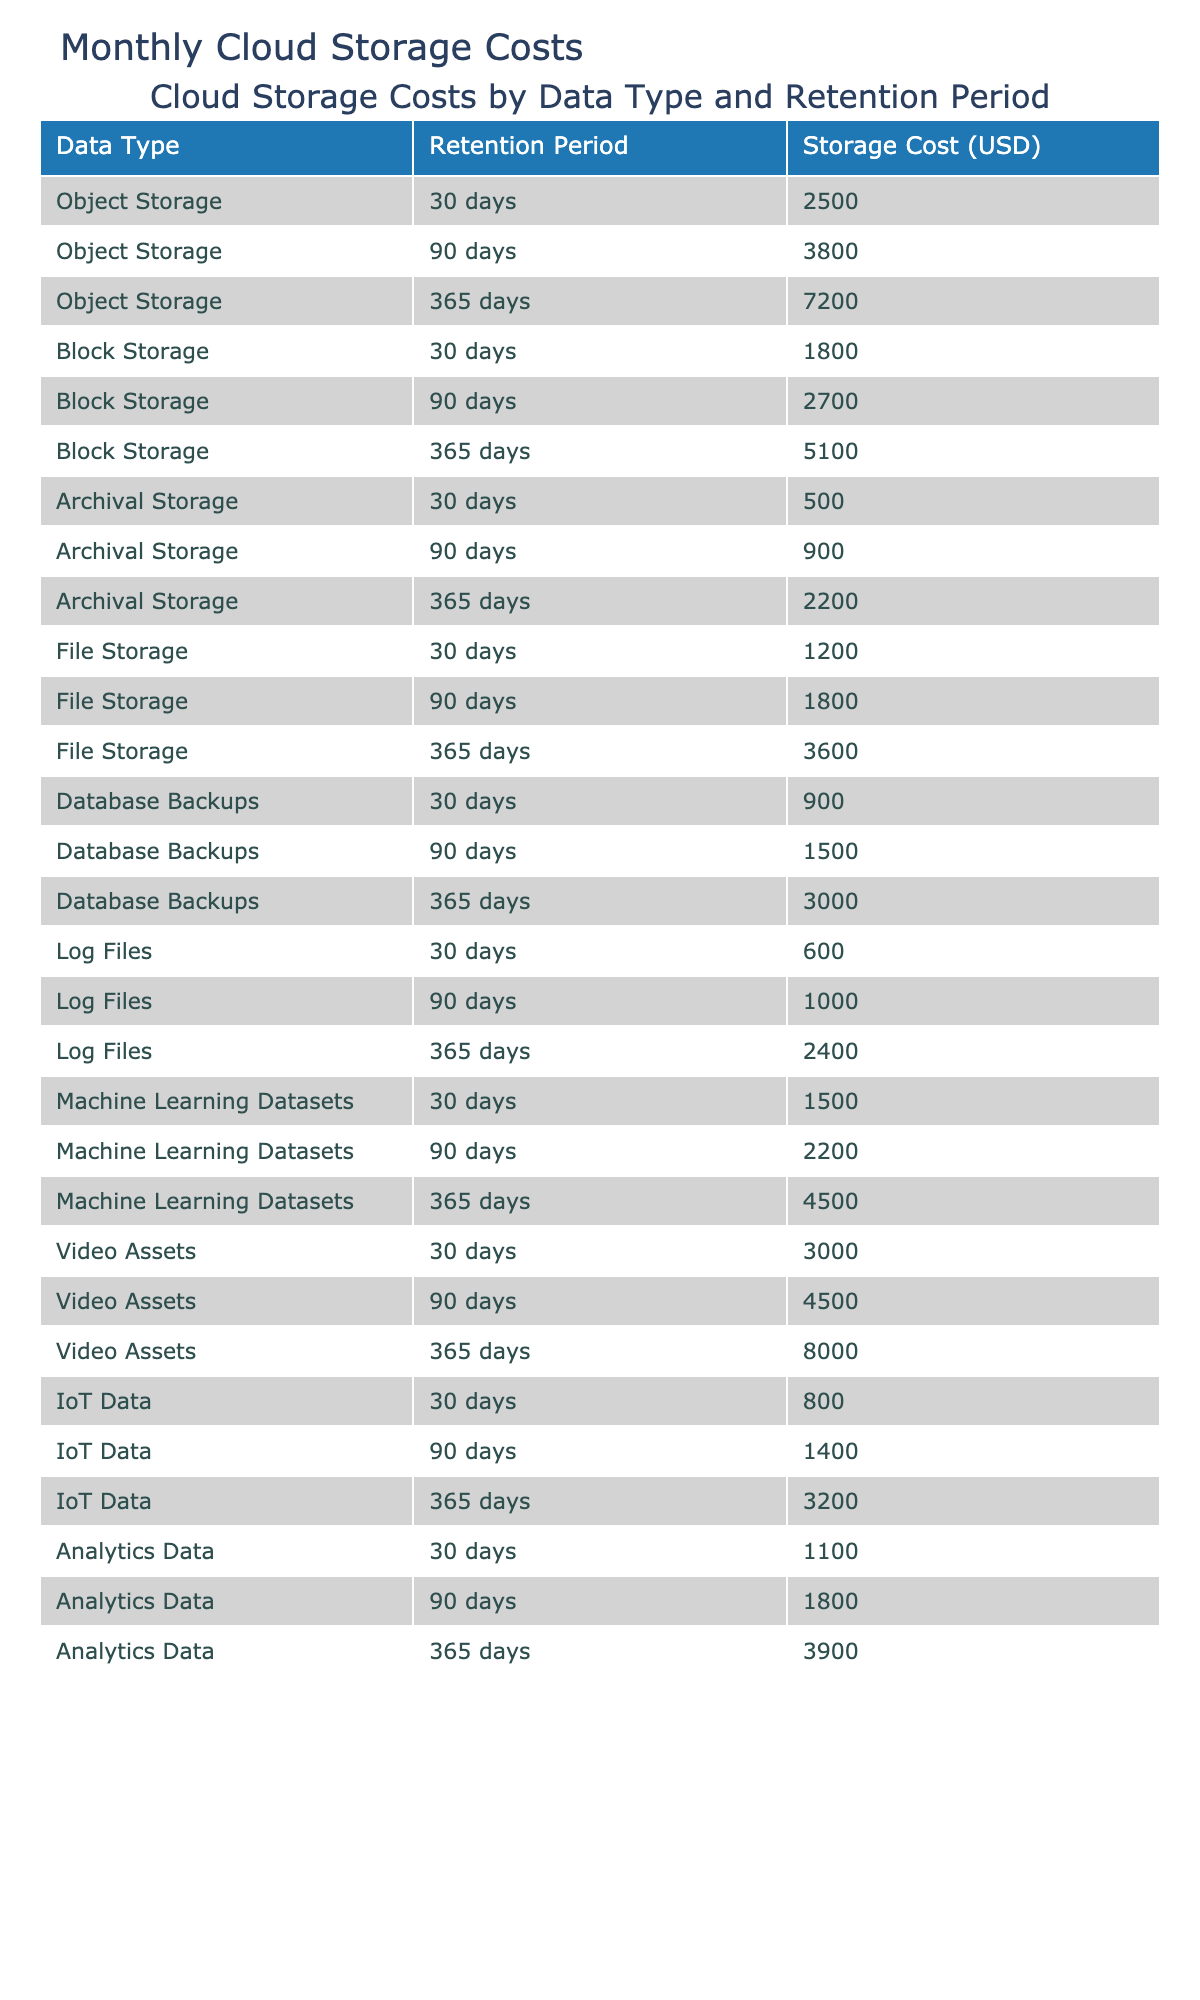What is the total storage cost for Archival Storage with a retention of 90 days? The storage cost for Archival Storage at a retention period of 90 days is listed in the table as 900 USD. No additional calculations are needed as it is a direct retrieval from the table.
Answer: 900 USD What is the average storage cost for File Storage across all retention periods? The storage costs for File Storage are 1200, 1800, and 3600 USD for the 30, 90, and 365 days retention periods respectively. The sum is 1200 + 1800 + 3600 = 6600 USD. There are 3 data points, so the average is 6600 / 3 = 2200 USD.
Answer: 2200 USD Which data type has the highest storage cost for the 365 days retention period? Checking the table for the storage costs at the 365 days retention period, Object Storage, Block Storage, Archival Storage, File Storage, Database Backups, Log Files, Machine Learning Datasets, Video Assets, IoT Data, and Analytics Data are reviewed. Among all these, Video Assets has the highest cost of 8000 USD.
Answer: Video Assets What is the total cost for all types of storage with a 30 days retention period? The storage costs for 30 days are: Object Storage (2500), Block Storage (1800), Archival Storage (500), File Storage (1200), Database Backups (900), Log Files (600), Machine Learning Datasets (1500), Video Assets (3000), IoT Data (800), and Analytics Data (1100). Adding these gives: 2500 + 1800 + 500 + 1200 + 900 + 600 + 1500 + 3000 + 800 + 1100 = 15500 USD.
Answer: 15500 USD Is the storage cost for Database Backups at a retention of 90 days higher than that of Block Storage with the same retention period? Looking at the table, Database Backups for 90 days costs 1500 USD, while Block Storage for the same retention period costs 2700 USD. Since 1500 is less than 2700, the statement is false.
Answer: No Which data type shows the least amount of cost for the 365 days retention period? Reviewing the data for the 365 days retention period, the costs are Object Storage (7200), Block Storage (5100), Archival Storage (2200), File Storage (3600), Database Backups (3000), Log Files (2400), Machine Learning Datasets (4500), Video Assets (8000), IoT Data (3200), and Analytics Data (3900). The least cost is for Archival Storage, at 2200 USD.
Answer: Archival Storage What is the combined storage cost for Machine Learning Datasets across all retention periods? Machine Learning Datasets have costs of 1500, 2200, and 4500 USD for 30, 90, and 365 days respectively. Summing these up: 1500 + 2200 + 4500 = 8200 USD.
Answer: 8200 USD Are the costs for 90 days retention period across all storage types greater than or less than 20000 USD? The costs for 90 days retention are: Object Storage (3800), Block Storage (2700), Archival Storage (900), File Storage (1800), Database Backups (1500), Log Files (1000), Machine Learning Datasets (2200), Video Assets (4500), IoT Data (1400), and Analytics Data (1800). Adding these amounts gives 3800 + 2700 + 900 + 1800 + 1500 + 1000 + 2200 + 4500 + 1400 + 1800 = 20000 USD, which means they are equal.
Answer: Equal What is the increase in cost for Object Storage when comparing the 30 days to the 365 days retention periods? Object Storage costs 2500 USD for the 30 days period and 7200 USD for the 365 days period. The increase in cost is calculated by subtracting the two: 7200 - 2500 = 4700 USD.
Answer: 4700 USD 